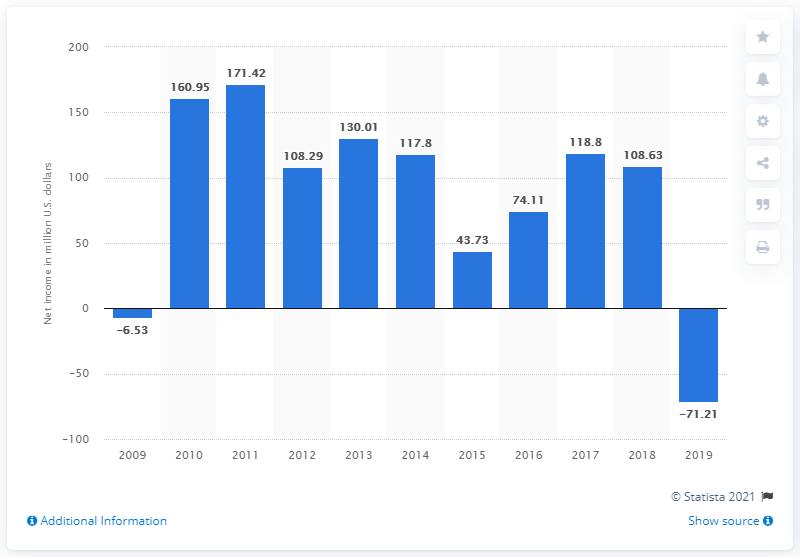List a handful of essential elements in this visual. In the year 2009, Sotheby's last reported a net loss of 71.21 million U.S. dollars. The net income of Sotheby's for the previous year was 108.63. 